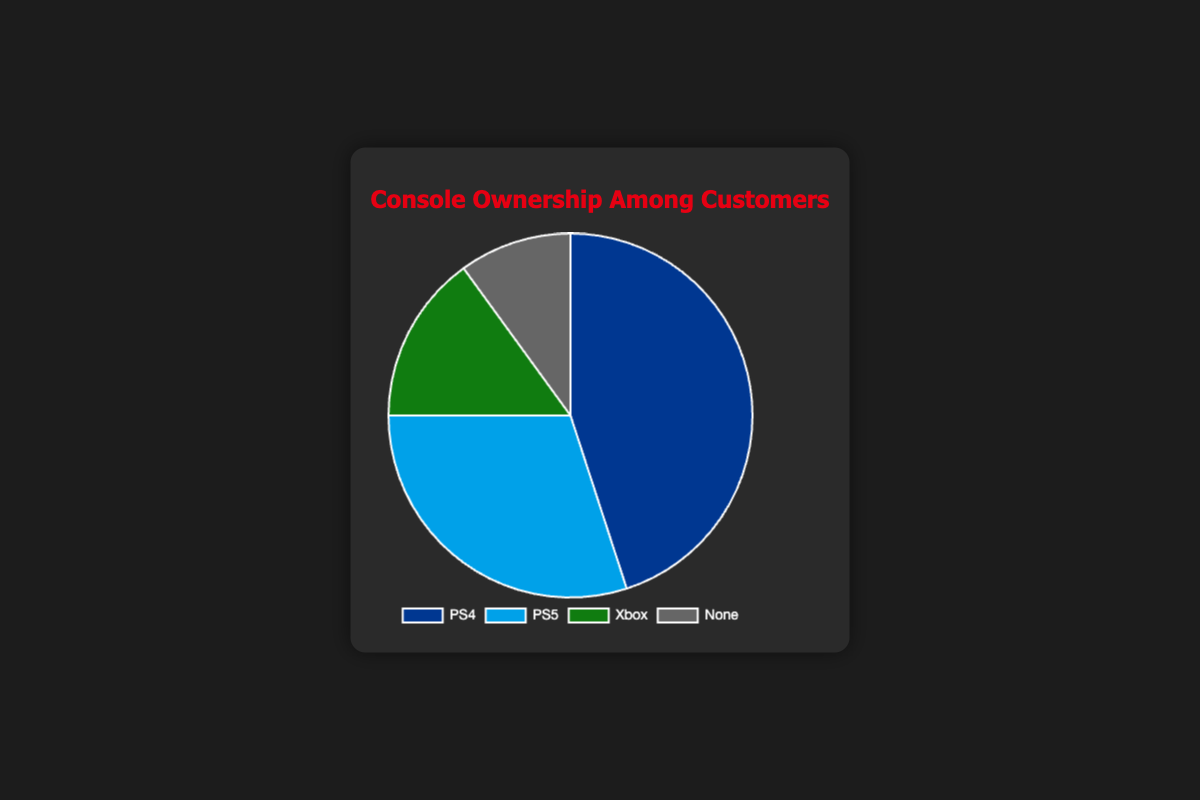What percentage of customers own a PS4? The slice labeled "PS4" represents 45% of the pie chart.
Answer: 45% How much larger is the PS5 ownership compared to Xbox ownership? The percentage for PS5 is 30%, and for Xbox, it is 15%. The difference is calculated by 30% - 15% = 15%.
Answer: 15% What is the combined ownership percentage of PS4 and PS5? Add the percentages for PS4 (45%) and PS5 (30%) to get the total ownership percentage: 45% + 30% = 75%.
Answer: 75% Which console ownership has the smallest percentage and what is it? Looking at the pie chart, the smallest slice is labeled "None" with 10%.
Answer: None, 10% Is the percentage of customers owning an Xbox greater, less than, or equal to the percentage of customers with no console? The Xbox ownership is 15%, and the ownership of no console is 10%. 15% is greater than 10%.
Answer: Greater What is the average percentage of customers owning the three types of consoles (PS4, PS5, Xbox)? Sum up the percentages for PS4 (45%), PS5 (30%), and Xbox (15%), then divide by 3: (45% + 30% + 15%) / 3 = 30%.
Answer: 30% Which console ownership group has the second highest percentage? The highest percentage is for PS4 (45%), and the second highest is for PS5 (30%).
Answer: PS5 If you combine the percentage of customers who own an Xbox with those who don’t own any console, what is the total percentage? Add the percentages for Xbox (15%) and None (10%): 15% + 10% = 25%.
Answer: 25% What are the visual colors representing PS4 and PS5 ownership? The color representing PS4 ownership is blue, and for PS5 ownership, it is light blue.
Answer: Blue, Light blue If the total number of surveyed customers is 100, how many customers do not own any console? Since 10% of customers have no console, out of 100 customers, 10% * 100 = 10 customers have no console.
Answer: 10 